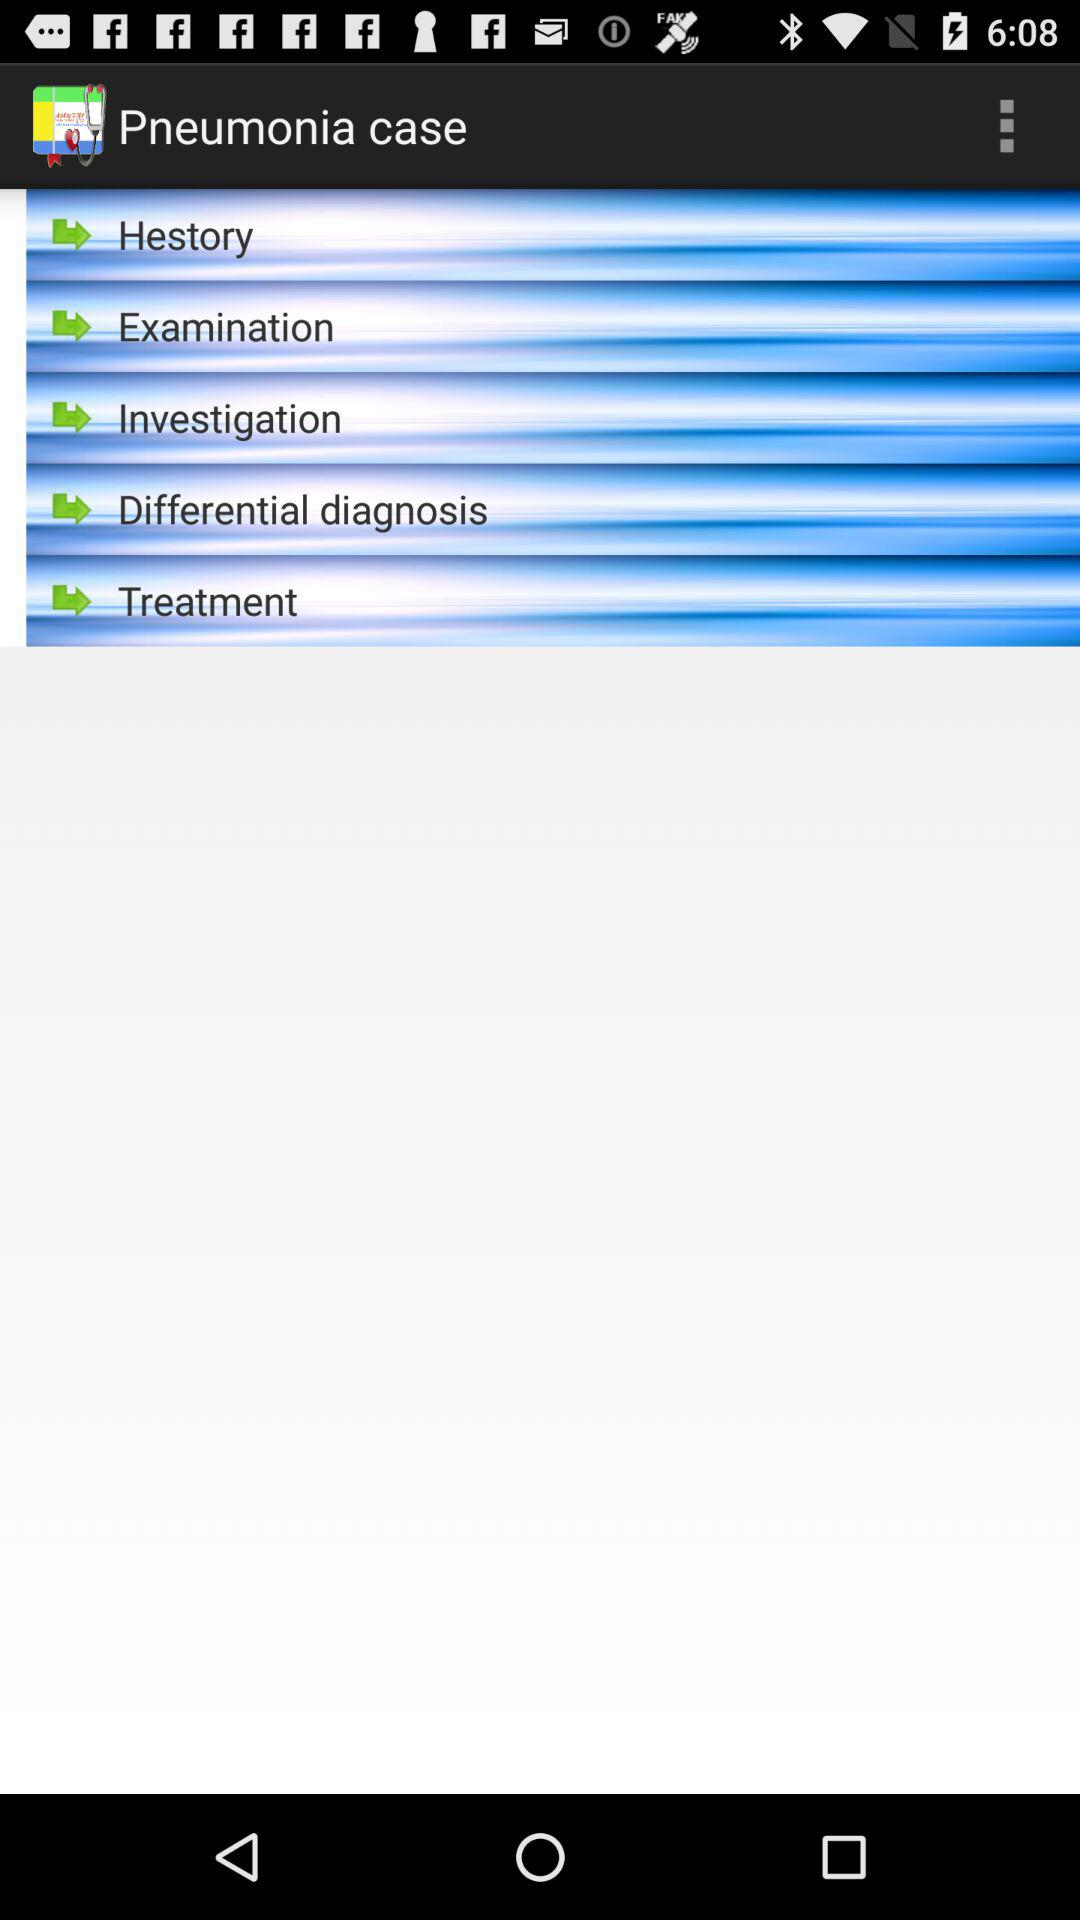How many green arrows are there on the Pneumonia case?
Answer the question using a single word or phrase. 5 